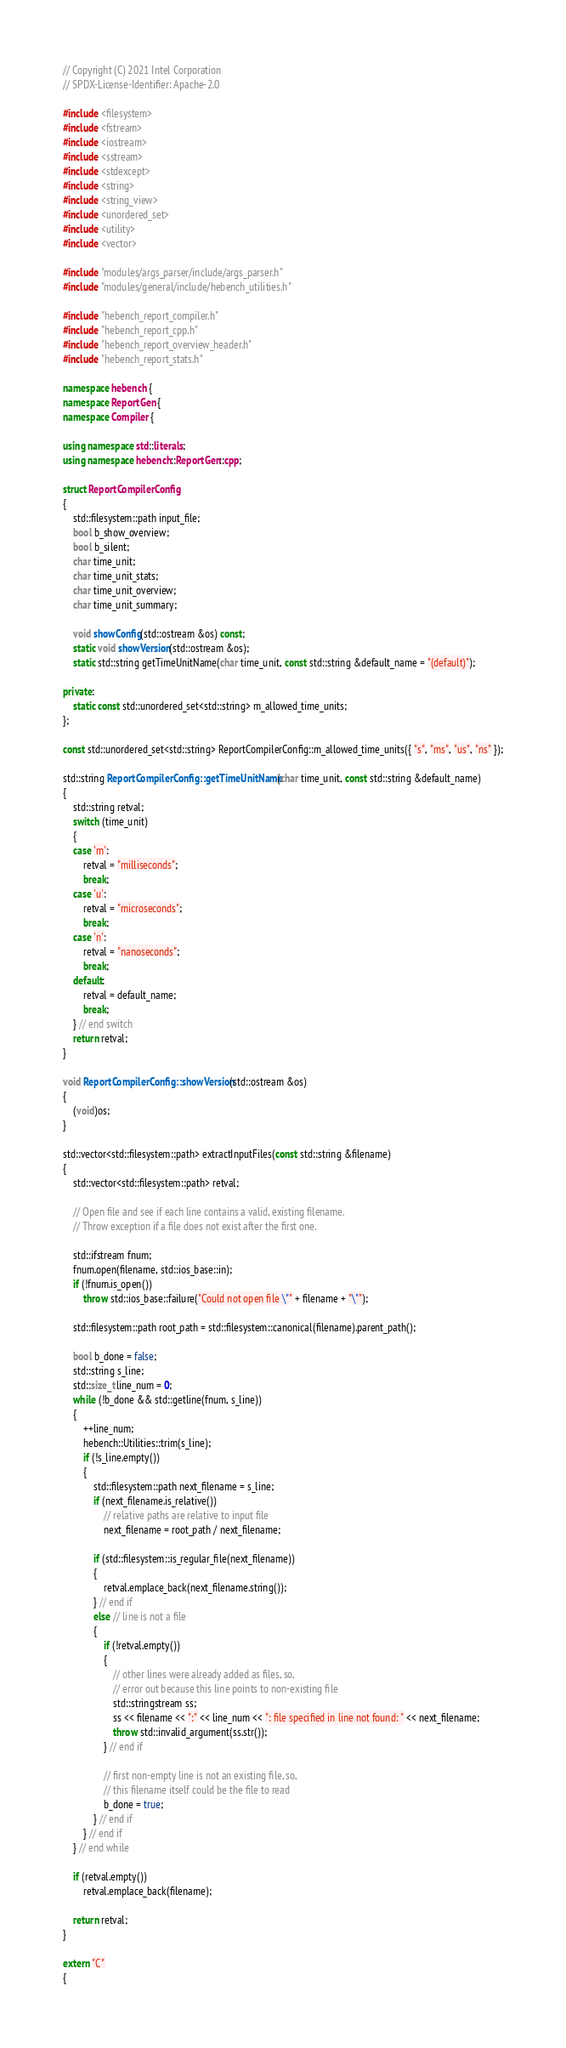Convert code to text. <code><loc_0><loc_0><loc_500><loc_500><_C++_>
// Copyright (C) 2021 Intel Corporation
// SPDX-License-Identifier: Apache-2.0

#include <filesystem>
#include <fstream>
#include <iostream>
#include <sstream>
#include <stdexcept>
#include <string>
#include <string_view>
#include <unordered_set>
#include <utility>
#include <vector>

#include "modules/args_parser/include/args_parser.h"
#include "modules/general/include/hebench_utilities.h"

#include "hebench_report_compiler.h"
#include "hebench_report_cpp.h"
#include "hebench_report_overview_header.h"
#include "hebench_report_stats.h"

namespace hebench {
namespace ReportGen {
namespace Compiler {

using namespace std::literals;
using namespace hebench::ReportGen::cpp;

struct ReportCompilerConfig
{
    std::filesystem::path input_file;
    bool b_show_overview;
    bool b_silent;
    char time_unit;
    char time_unit_stats;
    char time_unit_overview;
    char time_unit_summary;

    void showConfig(std::ostream &os) const;
    static void showVersion(std::ostream &os);
    static std::string getTimeUnitName(char time_unit, const std::string &default_name = "(default)");

private:
    static const std::unordered_set<std::string> m_allowed_time_units;
};

const std::unordered_set<std::string> ReportCompilerConfig::m_allowed_time_units({ "s", "ms", "us", "ns" });

std::string ReportCompilerConfig::getTimeUnitName(char time_unit, const std::string &default_name)
{
    std::string retval;
    switch (time_unit)
    {
    case 'm':
        retval = "milliseconds";
        break;
    case 'u':
        retval = "microseconds";
        break;
    case 'n':
        retval = "nanoseconds";
        break;
    default:
        retval = default_name;
        break;
    } // end switch
    return retval;
}

void ReportCompilerConfig::showVersion(std::ostream &os)
{
    (void)os;
}

std::vector<std::filesystem::path> extractInputFiles(const std::string &filename)
{
    std::vector<std::filesystem::path> retval;

    // Open file and see if each line contains a valid, existing filename.
    // Throw exception if a file does not exist after the first one.

    std::ifstream fnum;
    fnum.open(filename, std::ios_base::in);
    if (!fnum.is_open())
        throw std::ios_base::failure("Could not open file \"" + filename + "\"");

    std::filesystem::path root_path = std::filesystem::canonical(filename).parent_path();

    bool b_done = false;
    std::string s_line;
    std::size_t line_num = 0;
    while (!b_done && std::getline(fnum, s_line))
    {
        ++line_num;
        hebench::Utilities::trim(s_line);
        if (!s_line.empty())
        {
            std::filesystem::path next_filename = s_line;
            if (next_filename.is_relative())
                // relative paths are relative to input file
                next_filename = root_path / next_filename;

            if (std::filesystem::is_regular_file(next_filename))
            {
                retval.emplace_back(next_filename.string());
            } // end if
            else // line is not a file
            {
                if (!retval.empty())
                {
                    // other lines were already added as files, so,
                    // error out because this line points to non-existing file
                    std::stringstream ss;
                    ss << filename << ":" << line_num << ": file specified in line not found: " << next_filename;
                    throw std::invalid_argument(ss.str());
                } // end if

                // first non-empty line is not an existing file, so,
                // this filename itself could be the file to read
                b_done = true;
            } // end if
        } // end if
    } // end while

    if (retval.empty())
        retval.emplace_back(filename);

    return retval;
}

extern "C"
{
</code> 